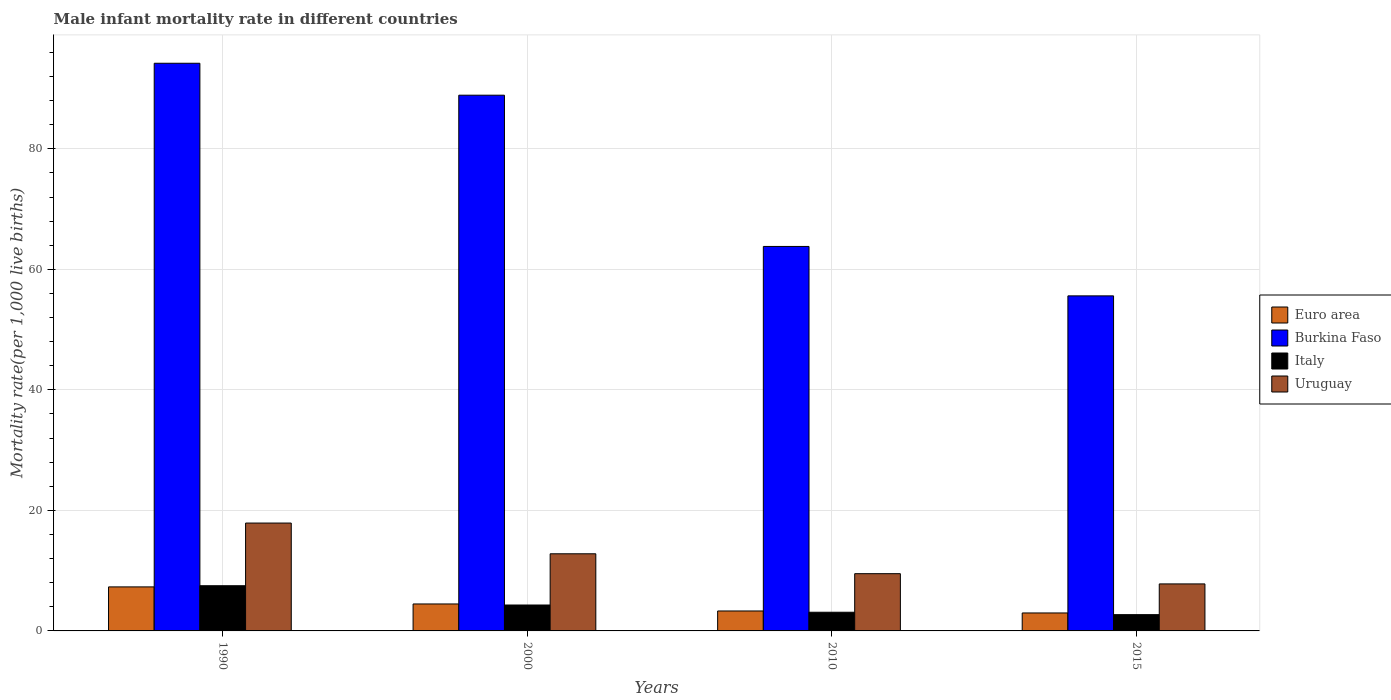How many groups of bars are there?
Your answer should be very brief. 4. Are the number of bars per tick equal to the number of legend labels?
Your response must be concise. Yes. Are the number of bars on each tick of the X-axis equal?
Provide a short and direct response. Yes. How many bars are there on the 1st tick from the left?
Provide a succinct answer. 4. How many bars are there on the 3rd tick from the right?
Give a very brief answer. 4. What is the label of the 4th group of bars from the left?
Ensure brevity in your answer.  2015. In how many cases, is the number of bars for a given year not equal to the number of legend labels?
Provide a succinct answer. 0. What is the male infant mortality rate in Euro area in 2000?
Your response must be concise. 4.47. Across all years, what is the maximum male infant mortality rate in Uruguay?
Provide a succinct answer. 17.9. In which year was the male infant mortality rate in Burkina Faso minimum?
Provide a succinct answer. 2015. What is the total male infant mortality rate in Uruguay in the graph?
Offer a very short reply. 48. What is the difference between the male infant mortality rate in Euro area in 1990 and that in 2000?
Your answer should be very brief. 2.83. What is the difference between the male infant mortality rate in Burkina Faso in 2000 and the male infant mortality rate in Euro area in 1990?
Give a very brief answer. 81.59. What is the average male infant mortality rate in Italy per year?
Your response must be concise. 4.4. In the year 2015, what is the difference between the male infant mortality rate in Burkina Faso and male infant mortality rate in Italy?
Ensure brevity in your answer.  52.9. In how many years, is the male infant mortality rate in Italy greater than 68?
Provide a succinct answer. 0. What is the ratio of the male infant mortality rate in Uruguay in 2000 to that in 2015?
Ensure brevity in your answer.  1.64. Is the male infant mortality rate in Burkina Faso in 1990 less than that in 2010?
Your answer should be compact. No. Is the difference between the male infant mortality rate in Burkina Faso in 1990 and 2015 greater than the difference between the male infant mortality rate in Italy in 1990 and 2015?
Ensure brevity in your answer.  Yes. What is the difference between the highest and the second highest male infant mortality rate in Uruguay?
Provide a succinct answer. 5.1. What is the difference between the highest and the lowest male infant mortality rate in Euro area?
Offer a very short reply. 4.32. In how many years, is the male infant mortality rate in Burkina Faso greater than the average male infant mortality rate in Burkina Faso taken over all years?
Offer a terse response. 2. What does the 3rd bar from the right in 2010 represents?
Provide a succinct answer. Burkina Faso. Is it the case that in every year, the sum of the male infant mortality rate in Burkina Faso and male infant mortality rate in Euro area is greater than the male infant mortality rate in Italy?
Make the answer very short. Yes. How many years are there in the graph?
Provide a short and direct response. 4. What is the difference between two consecutive major ticks on the Y-axis?
Your answer should be compact. 20. Are the values on the major ticks of Y-axis written in scientific E-notation?
Your response must be concise. No. Does the graph contain any zero values?
Provide a succinct answer. No. How are the legend labels stacked?
Provide a short and direct response. Vertical. What is the title of the graph?
Ensure brevity in your answer.  Male infant mortality rate in different countries. What is the label or title of the Y-axis?
Offer a terse response. Mortality rate(per 1,0 live births). What is the Mortality rate(per 1,000 live births) of Euro area in 1990?
Offer a terse response. 7.31. What is the Mortality rate(per 1,000 live births) of Burkina Faso in 1990?
Offer a very short reply. 94.2. What is the Mortality rate(per 1,000 live births) in Italy in 1990?
Offer a terse response. 7.5. What is the Mortality rate(per 1,000 live births) of Uruguay in 1990?
Your answer should be very brief. 17.9. What is the Mortality rate(per 1,000 live births) in Euro area in 2000?
Make the answer very short. 4.47. What is the Mortality rate(per 1,000 live births) in Burkina Faso in 2000?
Provide a succinct answer. 88.9. What is the Mortality rate(per 1,000 live births) in Euro area in 2010?
Your answer should be compact. 3.31. What is the Mortality rate(per 1,000 live births) in Burkina Faso in 2010?
Offer a terse response. 63.8. What is the Mortality rate(per 1,000 live births) of Italy in 2010?
Your answer should be very brief. 3.1. What is the Mortality rate(per 1,000 live births) in Euro area in 2015?
Your answer should be compact. 2.98. What is the Mortality rate(per 1,000 live births) in Burkina Faso in 2015?
Offer a terse response. 55.6. What is the Mortality rate(per 1,000 live births) of Italy in 2015?
Provide a short and direct response. 2.7. What is the Mortality rate(per 1,000 live births) in Uruguay in 2015?
Keep it short and to the point. 7.8. Across all years, what is the maximum Mortality rate(per 1,000 live births) of Euro area?
Give a very brief answer. 7.31. Across all years, what is the maximum Mortality rate(per 1,000 live births) in Burkina Faso?
Your answer should be compact. 94.2. Across all years, what is the minimum Mortality rate(per 1,000 live births) in Euro area?
Give a very brief answer. 2.98. Across all years, what is the minimum Mortality rate(per 1,000 live births) of Burkina Faso?
Provide a short and direct response. 55.6. What is the total Mortality rate(per 1,000 live births) in Euro area in the graph?
Make the answer very short. 18.07. What is the total Mortality rate(per 1,000 live births) in Burkina Faso in the graph?
Give a very brief answer. 302.5. What is the total Mortality rate(per 1,000 live births) in Italy in the graph?
Your answer should be very brief. 17.6. What is the total Mortality rate(per 1,000 live births) of Uruguay in the graph?
Your response must be concise. 48. What is the difference between the Mortality rate(per 1,000 live births) in Euro area in 1990 and that in 2000?
Keep it short and to the point. 2.83. What is the difference between the Mortality rate(per 1,000 live births) of Italy in 1990 and that in 2000?
Your response must be concise. 3.2. What is the difference between the Mortality rate(per 1,000 live births) in Euro area in 1990 and that in 2010?
Offer a very short reply. 4. What is the difference between the Mortality rate(per 1,000 live births) in Burkina Faso in 1990 and that in 2010?
Offer a terse response. 30.4. What is the difference between the Mortality rate(per 1,000 live births) of Italy in 1990 and that in 2010?
Your response must be concise. 4.4. What is the difference between the Mortality rate(per 1,000 live births) of Uruguay in 1990 and that in 2010?
Your response must be concise. 8.4. What is the difference between the Mortality rate(per 1,000 live births) in Euro area in 1990 and that in 2015?
Provide a short and direct response. 4.33. What is the difference between the Mortality rate(per 1,000 live births) in Burkina Faso in 1990 and that in 2015?
Provide a short and direct response. 38.6. What is the difference between the Mortality rate(per 1,000 live births) of Italy in 1990 and that in 2015?
Give a very brief answer. 4.8. What is the difference between the Mortality rate(per 1,000 live births) in Uruguay in 1990 and that in 2015?
Provide a succinct answer. 10.1. What is the difference between the Mortality rate(per 1,000 live births) in Euro area in 2000 and that in 2010?
Ensure brevity in your answer.  1.16. What is the difference between the Mortality rate(per 1,000 live births) of Burkina Faso in 2000 and that in 2010?
Your response must be concise. 25.1. What is the difference between the Mortality rate(per 1,000 live births) in Italy in 2000 and that in 2010?
Give a very brief answer. 1.2. What is the difference between the Mortality rate(per 1,000 live births) of Euro area in 2000 and that in 2015?
Provide a succinct answer. 1.49. What is the difference between the Mortality rate(per 1,000 live births) of Burkina Faso in 2000 and that in 2015?
Your response must be concise. 33.3. What is the difference between the Mortality rate(per 1,000 live births) in Euro area in 2010 and that in 2015?
Your answer should be compact. 0.33. What is the difference between the Mortality rate(per 1,000 live births) of Uruguay in 2010 and that in 2015?
Make the answer very short. 1.7. What is the difference between the Mortality rate(per 1,000 live births) of Euro area in 1990 and the Mortality rate(per 1,000 live births) of Burkina Faso in 2000?
Your answer should be compact. -81.59. What is the difference between the Mortality rate(per 1,000 live births) of Euro area in 1990 and the Mortality rate(per 1,000 live births) of Italy in 2000?
Offer a very short reply. 3.01. What is the difference between the Mortality rate(per 1,000 live births) in Euro area in 1990 and the Mortality rate(per 1,000 live births) in Uruguay in 2000?
Give a very brief answer. -5.49. What is the difference between the Mortality rate(per 1,000 live births) of Burkina Faso in 1990 and the Mortality rate(per 1,000 live births) of Italy in 2000?
Give a very brief answer. 89.9. What is the difference between the Mortality rate(per 1,000 live births) in Burkina Faso in 1990 and the Mortality rate(per 1,000 live births) in Uruguay in 2000?
Your answer should be very brief. 81.4. What is the difference between the Mortality rate(per 1,000 live births) in Euro area in 1990 and the Mortality rate(per 1,000 live births) in Burkina Faso in 2010?
Offer a terse response. -56.49. What is the difference between the Mortality rate(per 1,000 live births) in Euro area in 1990 and the Mortality rate(per 1,000 live births) in Italy in 2010?
Your response must be concise. 4.21. What is the difference between the Mortality rate(per 1,000 live births) of Euro area in 1990 and the Mortality rate(per 1,000 live births) of Uruguay in 2010?
Offer a very short reply. -2.19. What is the difference between the Mortality rate(per 1,000 live births) of Burkina Faso in 1990 and the Mortality rate(per 1,000 live births) of Italy in 2010?
Your answer should be compact. 91.1. What is the difference between the Mortality rate(per 1,000 live births) of Burkina Faso in 1990 and the Mortality rate(per 1,000 live births) of Uruguay in 2010?
Offer a very short reply. 84.7. What is the difference between the Mortality rate(per 1,000 live births) of Euro area in 1990 and the Mortality rate(per 1,000 live births) of Burkina Faso in 2015?
Make the answer very short. -48.29. What is the difference between the Mortality rate(per 1,000 live births) of Euro area in 1990 and the Mortality rate(per 1,000 live births) of Italy in 2015?
Provide a succinct answer. 4.61. What is the difference between the Mortality rate(per 1,000 live births) of Euro area in 1990 and the Mortality rate(per 1,000 live births) of Uruguay in 2015?
Your response must be concise. -0.49. What is the difference between the Mortality rate(per 1,000 live births) in Burkina Faso in 1990 and the Mortality rate(per 1,000 live births) in Italy in 2015?
Ensure brevity in your answer.  91.5. What is the difference between the Mortality rate(per 1,000 live births) in Burkina Faso in 1990 and the Mortality rate(per 1,000 live births) in Uruguay in 2015?
Your answer should be compact. 86.4. What is the difference between the Mortality rate(per 1,000 live births) of Euro area in 2000 and the Mortality rate(per 1,000 live births) of Burkina Faso in 2010?
Offer a very short reply. -59.33. What is the difference between the Mortality rate(per 1,000 live births) of Euro area in 2000 and the Mortality rate(per 1,000 live births) of Italy in 2010?
Give a very brief answer. 1.37. What is the difference between the Mortality rate(per 1,000 live births) of Euro area in 2000 and the Mortality rate(per 1,000 live births) of Uruguay in 2010?
Give a very brief answer. -5.03. What is the difference between the Mortality rate(per 1,000 live births) in Burkina Faso in 2000 and the Mortality rate(per 1,000 live births) in Italy in 2010?
Provide a succinct answer. 85.8. What is the difference between the Mortality rate(per 1,000 live births) of Burkina Faso in 2000 and the Mortality rate(per 1,000 live births) of Uruguay in 2010?
Ensure brevity in your answer.  79.4. What is the difference between the Mortality rate(per 1,000 live births) of Euro area in 2000 and the Mortality rate(per 1,000 live births) of Burkina Faso in 2015?
Offer a terse response. -51.13. What is the difference between the Mortality rate(per 1,000 live births) of Euro area in 2000 and the Mortality rate(per 1,000 live births) of Italy in 2015?
Make the answer very short. 1.77. What is the difference between the Mortality rate(per 1,000 live births) in Euro area in 2000 and the Mortality rate(per 1,000 live births) in Uruguay in 2015?
Give a very brief answer. -3.33. What is the difference between the Mortality rate(per 1,000 live births) of Burkina Faso in 2000 and the Mortality rate(per 1,000 live births) of Italy in 2015?
Make the answer very short. 86.2. What is the difference between the Mortality rate(per 1,000 live births) of Burkina Faso in 2000 and the Mortality rate(per 1,000 live births) of Uruguay in 2015?
Your response must be concise. 81.1. What is the difference between the Mortality rate(per 1,000 live births) in Italy in 2000 and the Mortality rate(per 1,000 live births) in Uruguay in 2015?
Offer a terse response. -3.5. What is the difference between the Mortality rate(per 1,000 live births) of Euro area in 2010 and the Mortality rate(per 1,000 live births) of Burkina Faso in 2015?
Your answer should be compact. -52.29. What is the difference between the Mortality rate(per 1,000 live births) in Euro area in 2010 and the Mortality rate(per 1,000 live births) in Italy in 2015?
Your answer should be compact. 0.61. What is the difference between the Mortality rate(per 1,000 live births) in Euro area in 2010 and the Mortality rate(per 1,000 live births) in Uruguay in 2015?
Offer a terse response. -4.49. What is the difference between the Mortality rate(per 1,000 live births) of Burkina Faso in 2010 and the Mortality rate(per 1,000 live births) of Italy in 2015?
Offer a very short reply. 61.1. What is the difference between the Mortality rate(per 1,000 live births) in Burkina Faso in 2010 and the Mortality rate(per 1,000 live births) in Uruguay in 2015?
Ensure brevity in your answer.  56. What is the average Mortality rate(per 1,000 live births) of Euro area per year?
Provide a succinct answer. 4.52. What is the average Mortality rate(per 1,000 live births) of Burkina Faso per year?
Offer a terse response. 75.62. In the year 1990, what is the difference between the Mortality rate(per 1,000 live births) of Euro area and Mortality rate(per 1,000 live births) of Burkina Faso?
Your response must be concise. -86.89. In the year 1990, what is the difference between the Mortality rate(per 1,000 live births) of Euro area and Mortality rate(per 1,000 live births) of Italy?
Offer a terse response. -0.19. In the year 1990, what is the difference between the Mortality rate(per 1,000 live births) of Euro area and Mortality rate(per 1,000 live births) of Uruguay?
Ensure brevity in your answer.  -10.59. In the year 1990, what is the difference between the Mortality rate(per 1,000 live births) in Burkina Faso and Mortality rate(per 1,000 live births) in Italy?
Keep it short and to the point. 86.7. In the year 1990, what is the difference between the Mortality rate(per 1,000 live births) of Burkina Faso and Mortality rate(per 1,000 live births) of Uruguay?
Provide a succinct answer. 76.3. In the year 1990, what is the difference between the Mortality rate(per 1,000 live births) of Italy and Mortality rate(per 1,000 live births) of Uruguay?
Your answer should be very brief. -10.4. In the year 2000, what is the difference between the Mortality rate(per 1,000 live births) of Euro area and Mortality rate(per 1,000 live births) of Burkina Faso?
Provide a short and direct response. -84.43. In the year 2000, what is the difference between the Mortality rate(per 1,000 live births) of Euro area and Mortality rate(per 1,000 live births) of Italy?
Offer a terse response. 0.17. In the year 2000, what is the difference between the Mortality rate(per 1,000 live births) of Euro area and Mortality rate(per 1,000 live births) of Uruguay?
Make the answer very short. -8.33. In the year 2000, what is the difference between the Mortality rate(per 1,000 live births) in Burkina Faso and Mortality rate(per 1,000 live births) in Italy?
Offer a terse response. 84.6. In the year 2000, what is the difference between the Mortality rate(per 1,000 live births) of Burkina Faso and Mortality rate(per 1,000 live births) of Uruguay?
Make the answer very short. 76.1. In the year 2000, what is the difference between the Mortality rate(per 1,000 live births) in Italy and Mortality rate(per 1,000 live births) in Uruguay?
Provide a succinct answer. -8.5. In the year 2010, what is the difference between the Mortality rate(per 1,000 live births) of Euro area and Mortality rate(per 1,000 live births) of Burkina Faso?
Give a very brief answer. -60.49. In the year 2010, what is the difference between the Mortality rate(per 1,000 live births) in Euro area and Mortality rate(per 1,000 live births) in Italy?
Provide a short and direct response. 0.21. In the year 2010, what is the difference between the Mortality rate(per 1,000 live births) of Euro area and Mortality rate(per 1,000 live births) of Uruguay?
Your answer should be very brief. -6.19. In the year 2010, what is the difference between the Mortality rate(per 1,000 live births) in Burkina Faso and Mortality rate(per 1,000 live births) in Italy?
Make the answer very short. 60.7. In the year 2010, what is the difference between the Mortality rate(per 1,000 live births) in Burkina Faso and Mortality rate(per 1,000 live births) in Uruguay?
Offer a very short reply. 54.3. In the year 2015, what is the difference between the Mortality rate(per 1,000 live births) in Euro area and Mortality rate(per 1,000 live births) in Burkina Faso?
Provide a short and direct response. -52.62. In the year 2015, what is the difference between the Mortality rate(per 1,000 live births) of Euro area and Mortality rate(per 1,000 live births) of Italy?
Your response must be concise. 0.28. In the year 2015, what is the difference between the Mortality rate(per 1,000 live births) in Euro area and Mortality rate(per 1,000 live births) in Uruguay?
Your answer should be very brief. -4.82. In the year 2015, what is the difference between the Mortality rate(per 1,000 live births) in Burkina Faso and Mortality rate(per 1,000 live births) in Italy?
Make the answer very short. 52.9. In the year 2015, what is the difference between the Mortality rate(per 1,000 live births) of Burkina Faso and Mortality rate(per 1,000 live births) of Uruguay?
Ensure brevity in your answer.  47.8. What is the ratio of the Mortality rate(per 1,000 live births) in Euro area in 1990 to that in 2000?
Your answer should be very brief. 1.63. What is the ratio of the Mortality rate(per 1,000 live births) of Burkina Faso in 1990 to that in 2000?
Ensure brevity in your answer.  1.06. What is the ratio of the Mortality rate(per 1,000 live births) in Italy in 1990 to that in 2000?
Give a very brief answer. 1.74. What is the ratio of the Mortality rate(per 1,000 live births) of Uruguay in 1990 to that in 2000?
Provide a short and direct response. 1.4. What is the ratio of the Mortality rate(per 1,000 live births) of Euro area in 1990 to that in 2010?
Give a very brief answer. 2.21. What is the ratio of the Mortality rate(per 1,000 live births) in Burkina Faso in 1990 to that in 2010?
Ensure brevity in your answer.  1.48. What is the ratio of the Mortality rate(per 1,000 live births) of Italy in 1990 to that in 2010?
Your answer should be compact. 2.42. What is the ratio of the Mortality rate(per 1,000 live births) of Uruguay in 1990 to that in 2010?
Offer a very short reply. 1.88. What is the ratio of the Mortality rate(per 1,000 live births) of Euro area in 1990 to that in 2015?
Your answer should be very brief. 2.45. What is the ratio of the Mortality rate(per 1,000 live births) in Burkina Faso in 1990 to that in 2015?
Your answer should be very brief. 1.69. What is the ratio of the Mortality rate(per 1,000 live births) in Italy in 1990 to that in 2015?
Offer a very short reply. 2.78. What is the ratio of the Mortality rate(per 1,000 live births) in Uruguay in 1990 to that in 2015?
Your answer should be very brief. 2.29. What is the ratio of the Mortality rate(per 1,000 live births) of Euro area in 2000 to that in 2010?
Provide a short and direct response. 1.35. What is the ratio of the Mortality rate(per 1,000 live births) of Burkina Faso in 2000 to that in 2010?
Provide a succinct answer. 1.39. What is the ratio of the Mortality rate(per 1,000 live births) of Italy in 2000 to that in 2010?
Ensure brevity in your answer.  1.39. What is the ratio of the Mortality rate(per 1,000 live births) of Uruguay in 2000 to that in 2010?
Give a very brief answer. 1.35. What is the ratio of the Mortality rate(per 1,000 live births) in Euro area in 2000 to that in 2015?
Give a very brief answer. 1.5. What is the ratio of the Mortality rate(per 1,000 live births) of Burkina Faso in 2000 to that in 2015?
Offer a terse response. 1.6. What is the ratio of the Mortality rate(per 1,000 live births) in Italy in 2000 to that in 2015?
Keep it short and to the point. 1.59. What is the ratio of the Mortality rate(per 1,000 live births) of Uruguay in 2000 to that in 2015?
Your answer should be very brief. 1.64. What is the ratio of the Mortality rate(per 1,000 live births) of Euro area in 2010 to that in 2015?
Your answer should be compact. 1.11. What is the ratio of the Mortality rate(per 1,000 live births) in Burkina Faso in 2010 to that in 2015?
Your response must be concise. 1.15. What is the ratio of the Mortality rate(per 1,000 live births) in Italy in 2010 to that in 2015?
Offer a very short reply. 1.15. What is the ratio of the Mortality rate(per 1,000 live births) in Uruguay in 2010 to that in 2015?
Make the answer very short. 1.22. What is the difference between the highest and the second highest Mortality rate(per 1,000 live births) in Euro area?
Keep it short and to the point. 2.83. What is the difference between the highest and the second highest Mortality rate(per 1,000 live births) of Burkina Faso?
Your response must be concise. 5.3. What is the difference between the highest and the lowest Mortality rate(per 1,000 live births) in Euro area?
Ensure brevity in your answer.  4.33. What is the difference between the highest and the lowest Mortality rate(per 1,000 live births) in Burkina Faso?
Your response must be concise. 38.6. 